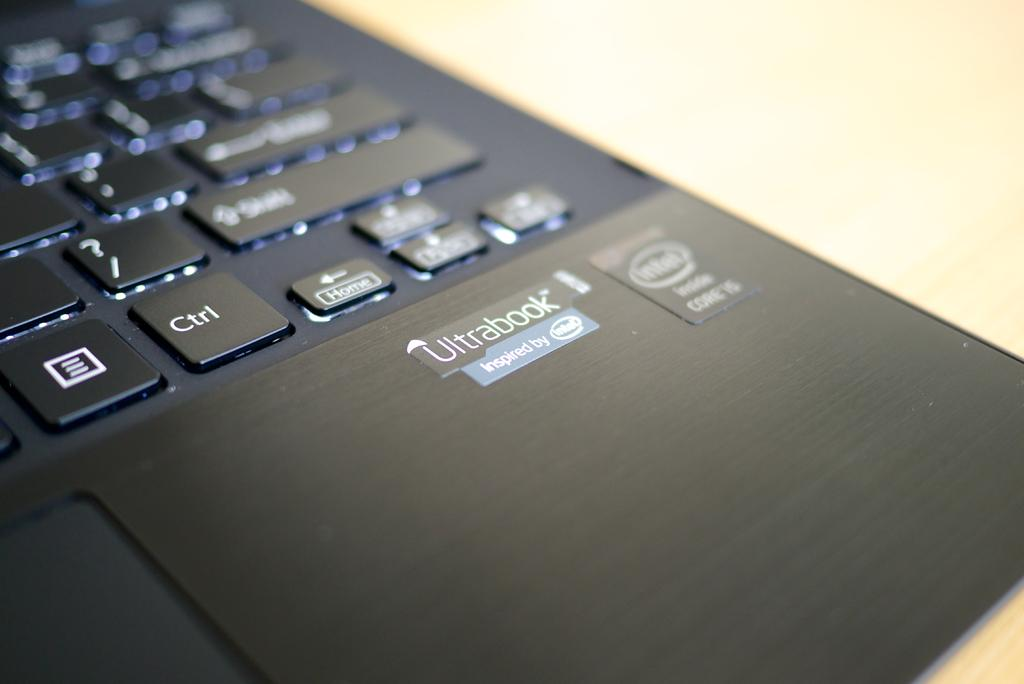<image>
Share a concise interpretation of the image provided. The lower right corner part of a intel processor laptop with part of the keyboard visible and lit up. 